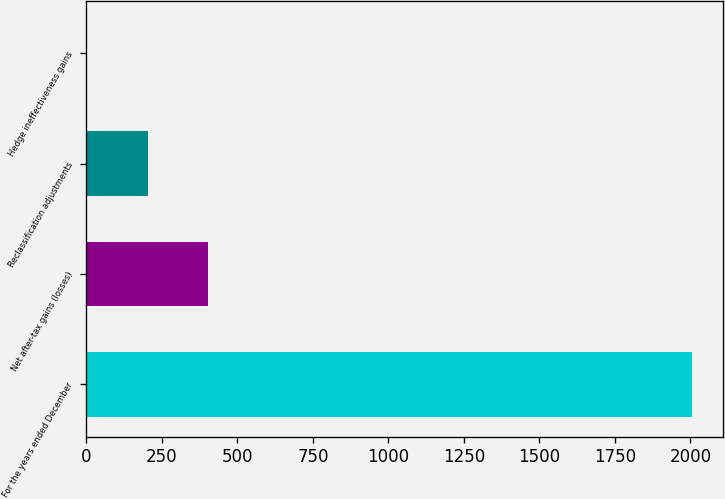Convert chart. <chart><loc_0><loc_0><loc_500><loc_500><bar_chart><fcel>For the years ended December<fcel>Net after-tax gains (losses)<fcel>Reclassification adjustments<fcel>Hedge ineffectiveness gains<nl><fcel>2006<fcel>402.8<fcel>202.4<fcel>2<nl></chart> 